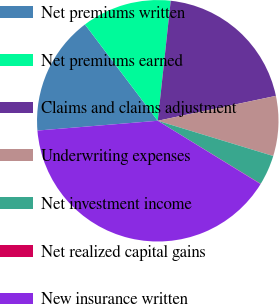Convert chart. <chart><loc_0><loc_0><loc_500><loc_500><pie_chart><fcel>Net premiums written<fcel>Net premiums earned<fcel>Claims and claims adjustment<fcel>Underwriting expenses<fcel>Net investment income<fcel>Net realized capital gains<fcel>New insurance written<nl><fcel>15.99%<fcel>12.01%<fcel>19.98%<fcel>8.02%<fcel>4.03%<fcel>0.04%<fcel>39.92%<nl></chart> 